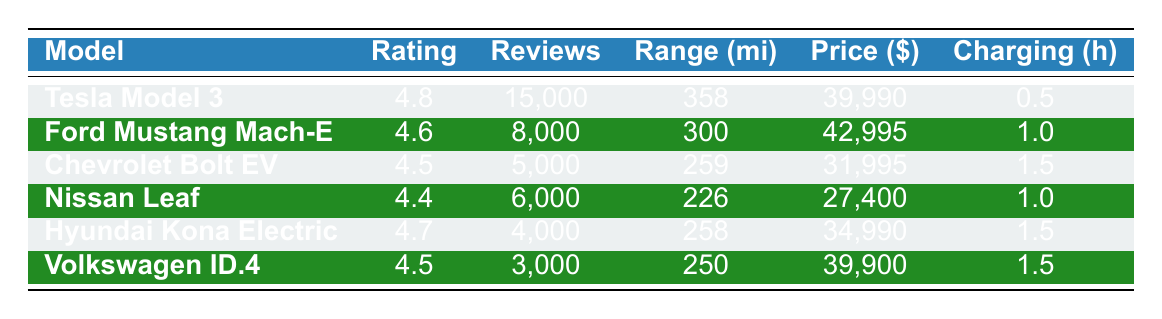What is the highest consumer rating among the listed electric car models? The consumer ratings for each model are as follows: Tesla Model 3 (4.8), Ford Mustang Mach-E (4.6), Chevrolet Bolt EV (4.5), Nissan Leaf (4.4), Hyundai Kona Electric (4.7), and Volkswagen ID.4 (4.5). The highest rating is 4.8 from the Tesla Model 3.
Answer: 4.8 Which electric car has the longest range? The range for each model is: Tesla Model 3 (358 miles), Ford Mustang Mach-E (300 miles), Chevrolet Bolt EV (259 miles), Nissan Leaf (226 miles), Hyundai Kona Electric (258 miles), and Volkswagen ID.4 (250 miles). The longest range is 358 miles from the Tesla Model 3.
Answer: 358 miles Are there more reviews for the Ford Mustang Mach-E than for the Hyundai Kona Electric? The Ford Mustang Mach-E has 8000 reviews and the Hyundai Kona Electric has 4000 reviews. Since 8000 is greater than 4000, the statement is true.
Answer: Yes What is the price difference between the cheapest and the most expensive electric car models in this table? The cheapest model is the Nissan Leaf at $27,400 and the most expensive is the Ford Mustang Mach-E at $42,995. The price difference is calculated as $42,995 - $27,400 = $15,595.
Answer: $15,595 What is the average consumer rating of the listed electric car models? The consumer ratings are: 4.8, 4.6, 4.5, 4.4, 4.7, and 4.5. To find the average, sum these ratings: 4.8 + 4.6 + 4.5 + 4.4 + 4.7 + 4.5 = 27.5. Divide by the number of models (6): 27.5 / 6 = 4.5833, which rounds to 4.58.
Answer: 4.58 Is there any electric car model in the list that has a charging time of less than 1 hour? The charging times listed are: Tesla Model 3 (0.5 hours), Ford Mustang Mach-E (1 hour), Chevrolet Bolt EV (1.5 hours), Nissan Leaf (1 hour), Hyundai Kona Electric (1.5 hours), and Volkswagen ID.4 (1.5 hours). Since the Tesla Model 3 has a charging time of 0.5 hours, which is less than 1 hour, the answer is true.
Answer: Yes Which model has the lowest starting price and what is that price? The starting prices are Nissan Leaf ($27,400), Chevrolet Bolt EV ($31,995), Hyundai Kona Electric ($34,990), Volkswagen ID.4 ($39,900), Ford Mustang Mach-E ($42,995), and Tesla Model 3 ($39,990). The lowest starting price is from the Nissan Leaf at $27,400.
Answer: $27,400 